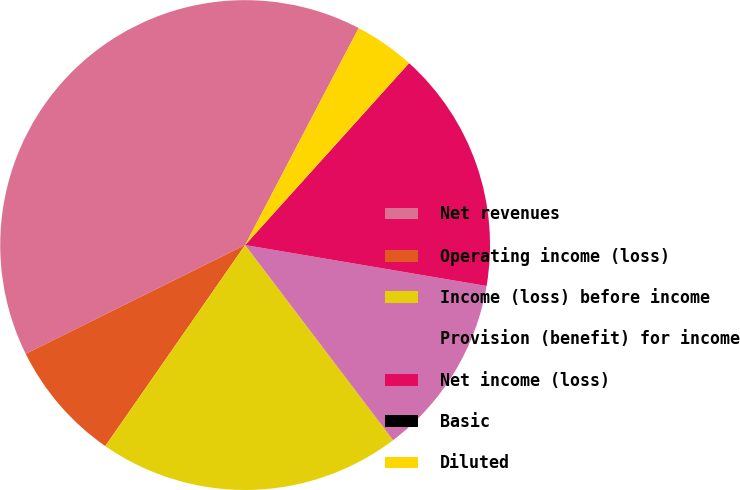Convert chart. <chart><loc_0><loc_0><loc_500><loc_500><pie_chart><fcel>Net revenues<fcel>Operating income (loss)<fcel>Income (loss) before income<fcel>Provision (benefit) for income<fcel>Net income (loss)<fcel>Basic<fcel>Diluted<nl><fcel>40.0%<fcel>8.0%<fcel>20.0%<fcel>12.0%<fcel>16.0%<fcel>0.0%<fcel>4.0%<nl></chart> 